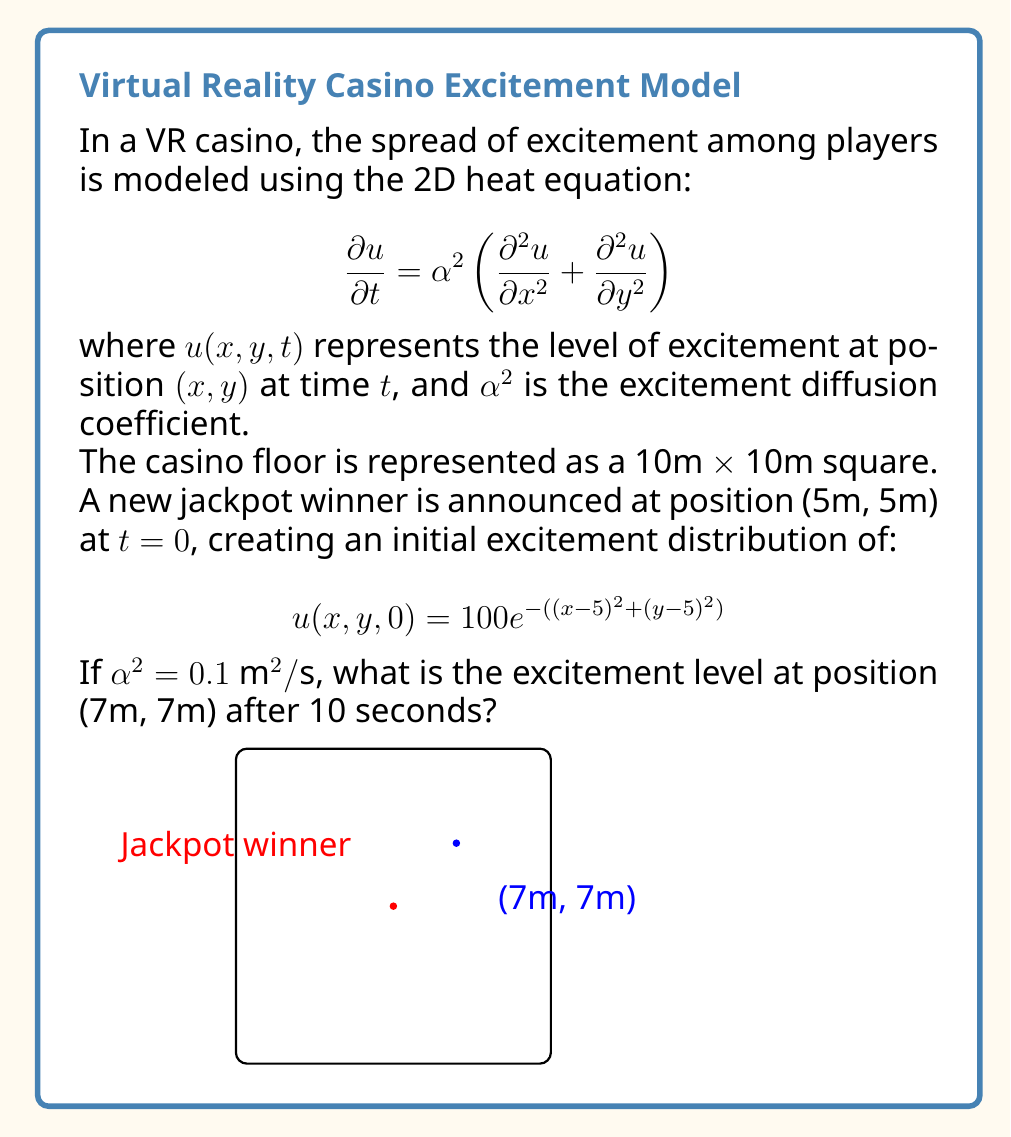Show me your answer to this math problem. To solve this problem, we need to use the solution of the 2D heat equation with an initial point source. The solution is given by:

$$u(x,y,t) = \frac{M}{4\pi\alpha^2t}e^{-\frac{(x-x_0)^2 + (y-y_0)^2}{4\alpha^2t}}$$

where $(x_0, y_0)$ is the initial point source location and $M$ is the initial intensity.

Step 1: Determine $M$
The initial condition gives us:
$$100e^{-((x-5)^2 + (y-5)^2)} = \frac{M}{4\pi\alpha^2 \cdot 0}e^{-\frac{(x-5)^2 + (y-5)^2}{4\alpha^2 \cdot 0}}$$
This implies $M = 400\pi\alpha^2 = 40\pi$.

Step 2: Substitute values
Now we can substitute the known values:
- $\alpha^2 = 0.1 \text{ m}^2/\text{s}$
- $t = 10 \text{ s}$
- $(x, y) = (7, 7)$
- $(x_0, y_0) = (5, 5)$
- $M = 40\pi$

$$u(7,7,10) = \frac{40\pi}{4\pi \cdot 0.1 \cdot 10}e^{-\frac{(7-5)^2 + (7-5)^2}{4 \cdot 0.1 \cdot 10}}$$

Step 3: Simplify and calculate
$$u(7,7,10) = 10 \cdot e^{-\frac{8}{4}} = 10 \cdot e^{-2} \approx 1.353$$

Therefore, the excitement level at position (7m, 7m) after 10 seconds is approximately 1.353.
Answer: 1.353 